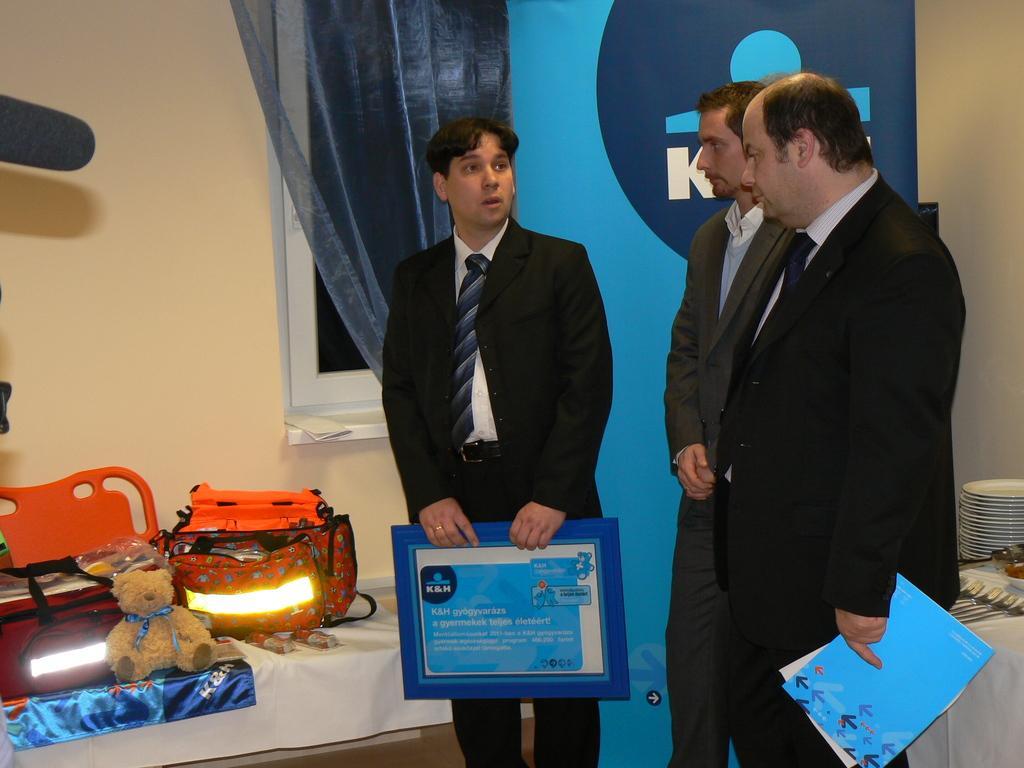Describe this image in one or two sentences. In the middle a man is standing, he wore a black color coat, trouser, tie and also holding a blue color file in his hands. On the left side there are lights and a teddy bear. 